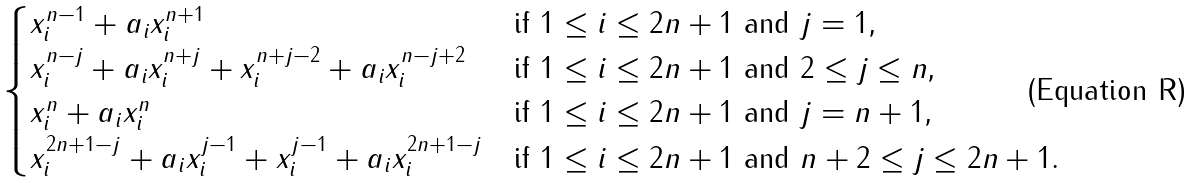Convert formula to latex. <formula><loc_0><loc_0><loc_500><loc_500>\begin{cases} x _ { i } ^ { n - 1 } + a _ { i } x _ { i } ^ { n + 1 } & \text {if $1 \leq i \leq 2n+1$ and $j = 1$,} \\ x _ { i } ^ { n - j } + a _ { i } x _ { i } ^ { n + j } + x _ { i } ^ { n + j - 2 } + a _ { i } x _ { i } ^ { n - j + 2 } & \text {if $1 \leq i \leq 2n+1$ and $2 \leq j \leq n$,} \\ x _ { i } ^ { n } + a _ { i } x _ { i } ^ { n } & \text {if $1 \leq i \leq 2n+1$ and $j = n+1$,} \\ x _ { i } ^ { 2 n + 1 - j } + a _ { i } x _ { i } ^ { j - 1 } + x _ { i } ^ { j - 1 } + a _ { i } x _ { i } ^ { 2 n + 1 - j } & \text {if $1 \leq i \leq 2n+1$ and $n+2 \leq j \leq 2n+1$.} \end{cases}</formula> 